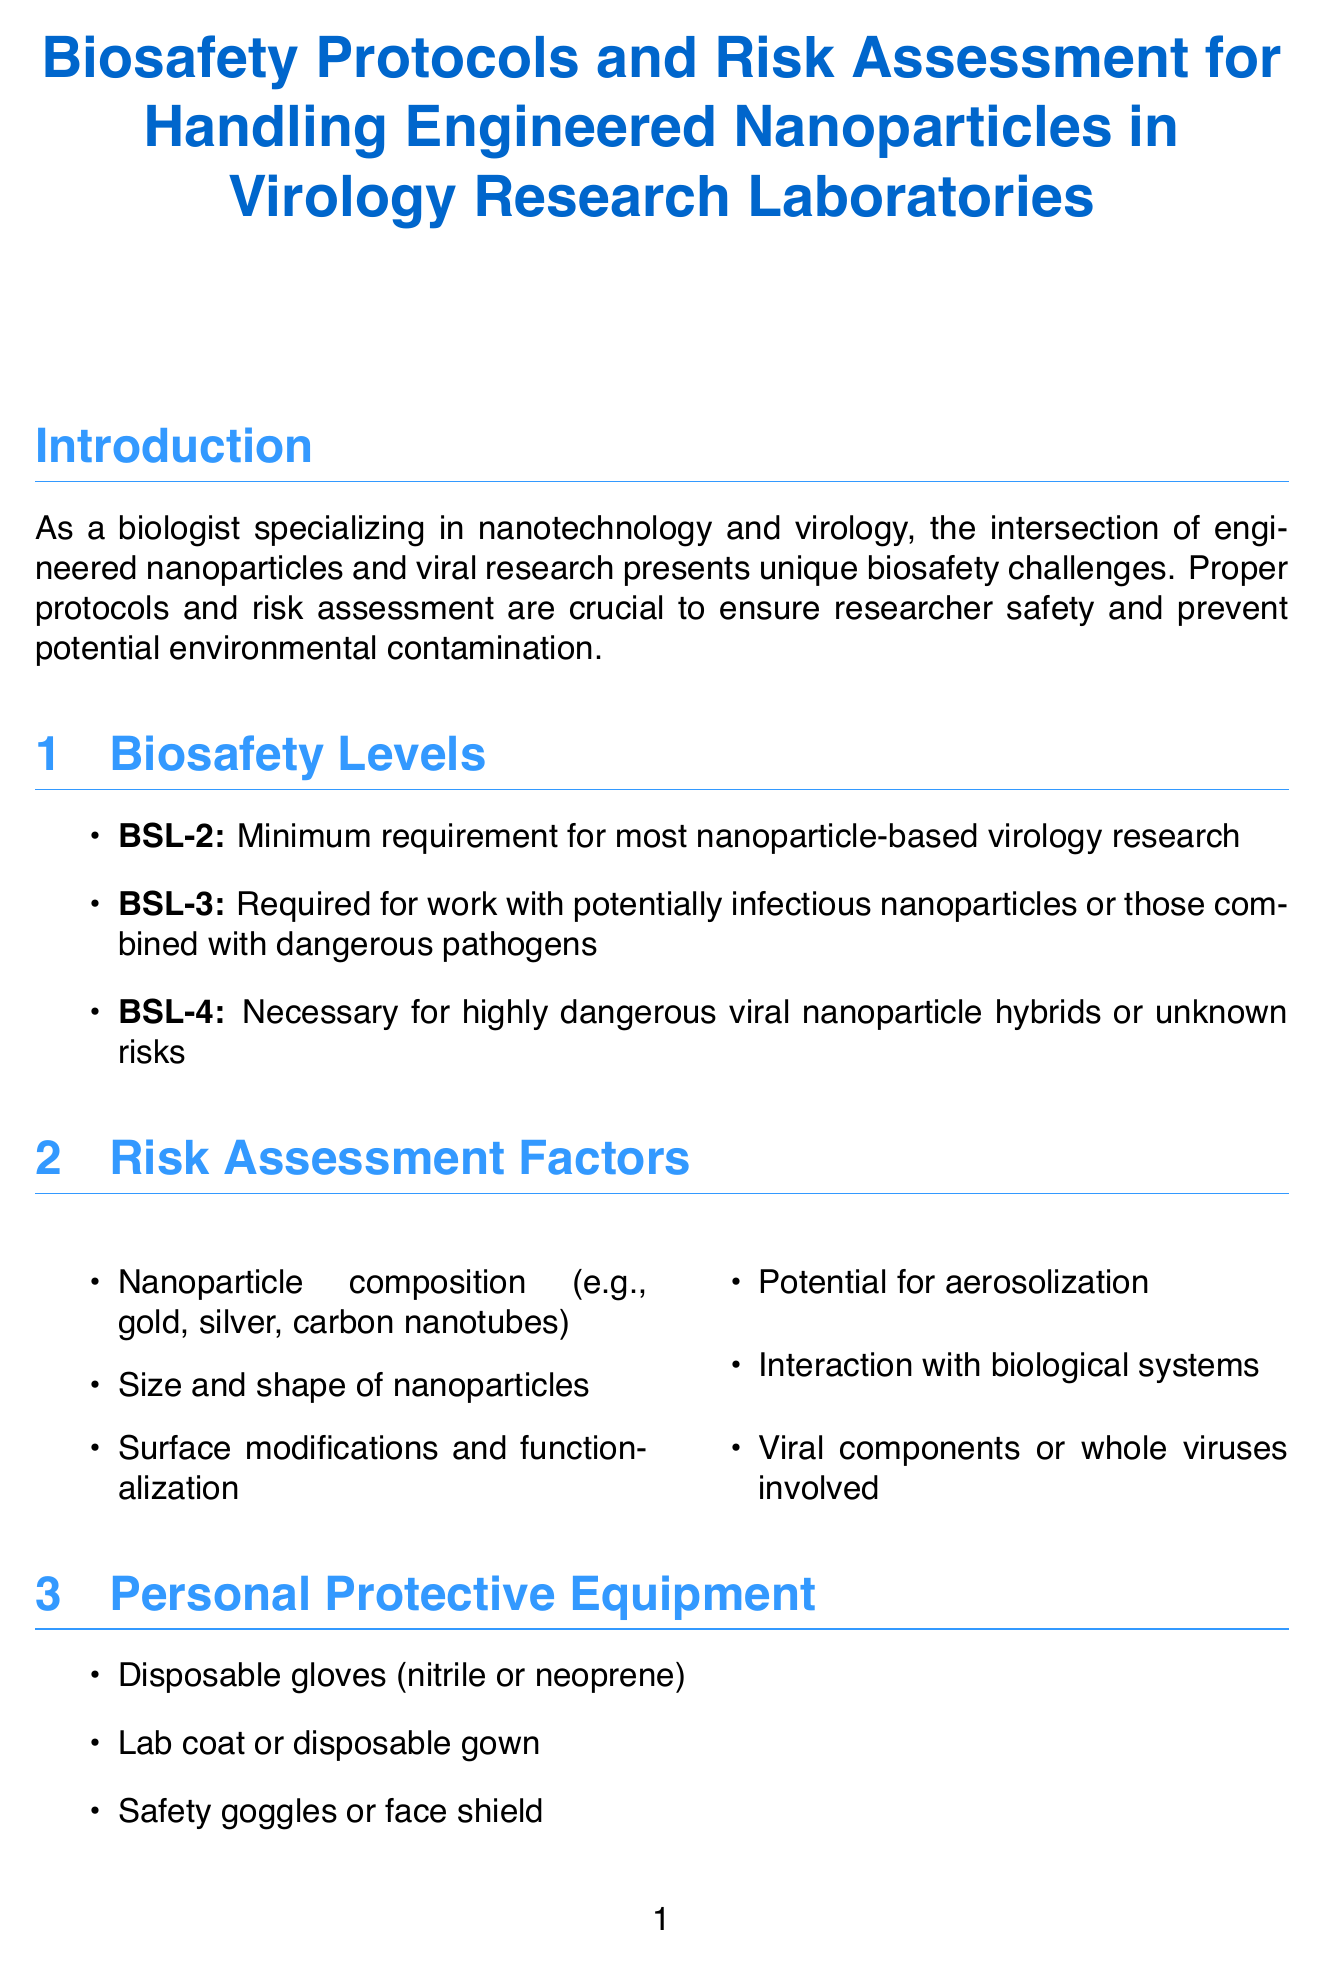What is the title of the report? The title of the report is explicitly stated at the top of the document.
Answer: Biosafety Protocols and Risk Assessment for Handling Engineered Nanoparticles in Virology Research Laboratories What is the minimum biosafety level for nanoparticle-based virology research? The document specifies the requirements for different biosafety levels in the section on biosafety levels.
Answer: BSL-2 Which organization published the Laboratory Biosafety Manual? The document lists regulatory guidelines and their associated organizations, providing clear attribution.
Answer: World Health Organization (WHO) What year did the accidental exposure case in the CDC occur? The case studies section includes specific years for reported incidents, highlighting crucial incidents in the field.
Answer: 2019 What are the primary containment measures listed? The engineering controls section outlines specific containment measures, identifying the standards for safety.
Answer: Certified Class II Biological Safety Cabinet How many training requirements are listed in the document? The training requirements section enumerates several specific training needs for researchers, emphasizing educational aspects.
Answer: Five What is one potential risk assessment factor mentioned? Risk assessment factors are detailed in their respective section, and one of them is explicitly stated in the document.
Answer: Nanoparticle composition What equipment is recommended for personal protection? The personal protective equipment section details the various necessary protective gear for laboratory safety.
Answer: Disposable gloves (nitrile or neoprene) What is one recommendation for future considerations? The future considerations section suggests upcoming needs in biosafety research, emphasizing progressive measures for safety improvement.
Answer: Development of nanoparticle-specific biosafety levels 